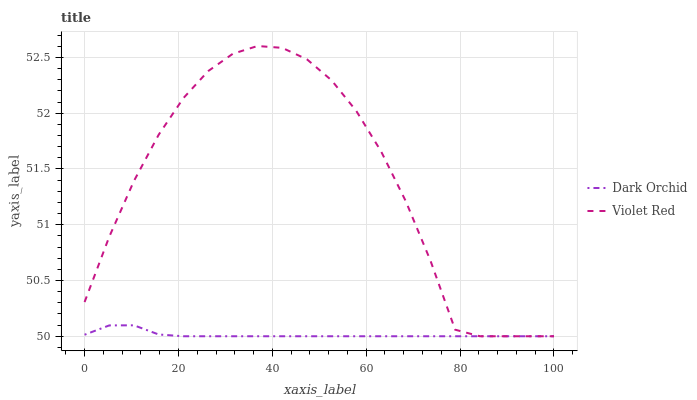Does Dark Orchid have the minimum area under the curve?
Answer yes or no. Yes. Does Violet Red have the maximum area under the curve?
Answer yes or no. Yes. Does Dark Orchid have the maximum area under the curve?
Answer yes or no. No. Is Dark Orchid the smoothest?
Answer yes or no. Yes. Is Violet Red the roughest?
Answer yes or no. Yes. Is Dark Orchid the roughest?
Answer yes or no. No. Does Violet Red have the lowest value?
Answer yes or no. Yes. Does Violet Red have the highest value?
Answer yes or no. Yes. Does Dark Orchid have the highest value?
Answer yes or no. No. Does Dark Orchid intersect Violet Red?
Answer yes or no. Yes. Is Dark Orchid less than Violet Red?
Answer yes or no. No. Is Dark Orchid greater than Violet Red?
Answer yes or no. No. 